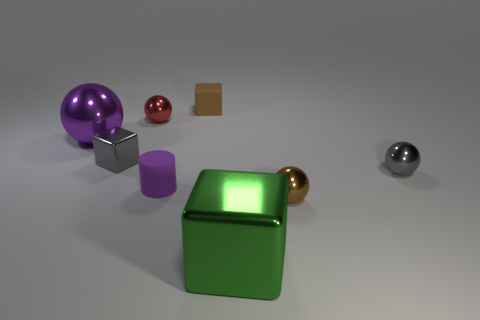The tiny shiny block is what color?
Your response must be concise. Gray. Is there a object that has the same color as the cylinder?
Make the answer very short. Yes. There is a gray thing to the right of the tiny brown thing that is in front of the large object that is behind the green metal thing; what shape is it?
Make the answer very short. Sphere. What is the tiny brown thing that is in front of the small purple rubber object made of?
Provide a short and direct response. Metal. What is the size of the metal cube right of the small brown thing that is behind the tiny gray metallic thing right of the tiny purple cylinder?
Your response must be concise. Large. Do the brown metal ball and the brown thing that is behind the gray ball have the same size?
Your answer should be very brief. Yes. The large object that is behind the brown ball is what color?
Provide a succinct answer. Purple. There is a small metal object that is the same color as the small metal block; what shape is it?
Offer a very short reply. Sphere. The tiny matte object that is in front of the purple sphere has what shape?
Make the answer very short. Cylinder. How many cyan objects are either small spheres or big cubes?
Your answer should be very brief. 0. 